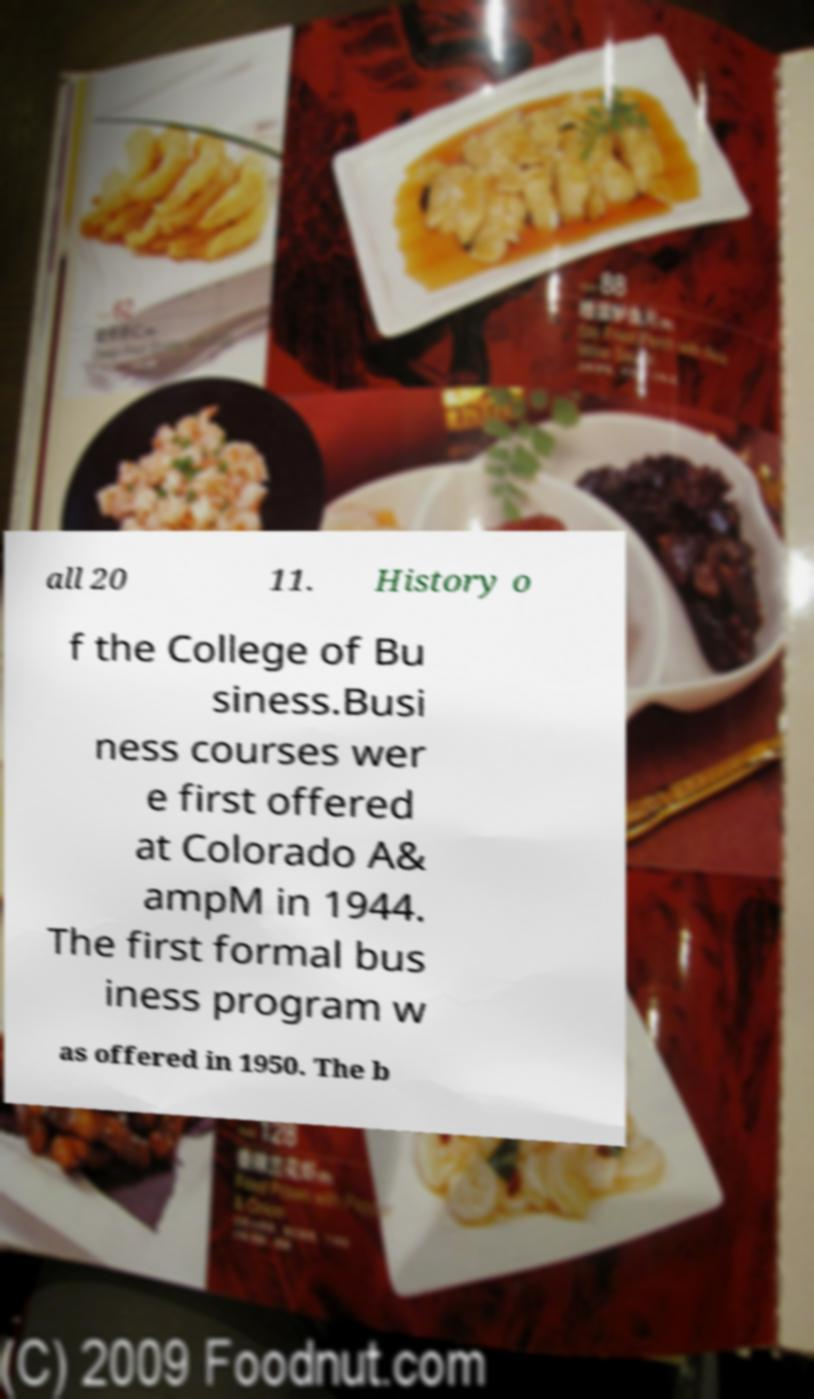Please read and relay the text visible in this image. What does it say? all 20 11. History o f the College of Bu siness.Busi ness courses wer e first offered at Colorado A& ampM in 1944. The first formal bus iness program w as offered in 1950. The b 